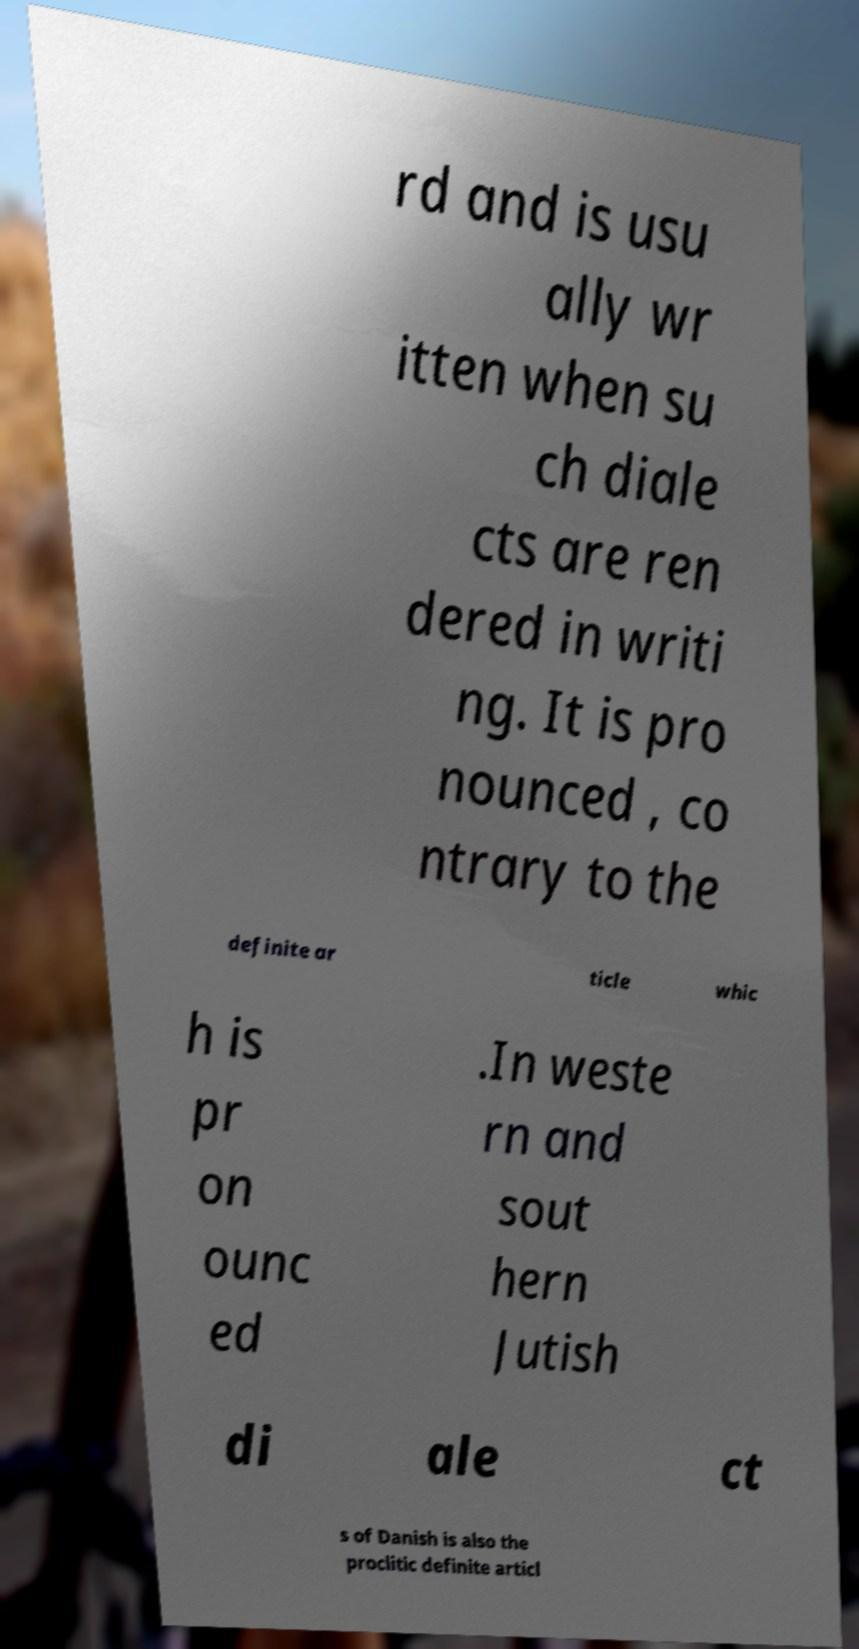Please identify and transcribe the text found in this image. rd and is usu ally wr itten when su ch diale cts are ren dered in writi ng. It is pro nounced , co ntrary to the definite ar ticle whic h is pr on ounc ed .In weste rn and sout hern Jutish di ale ct s of Danish is also the proclitic definite articl 